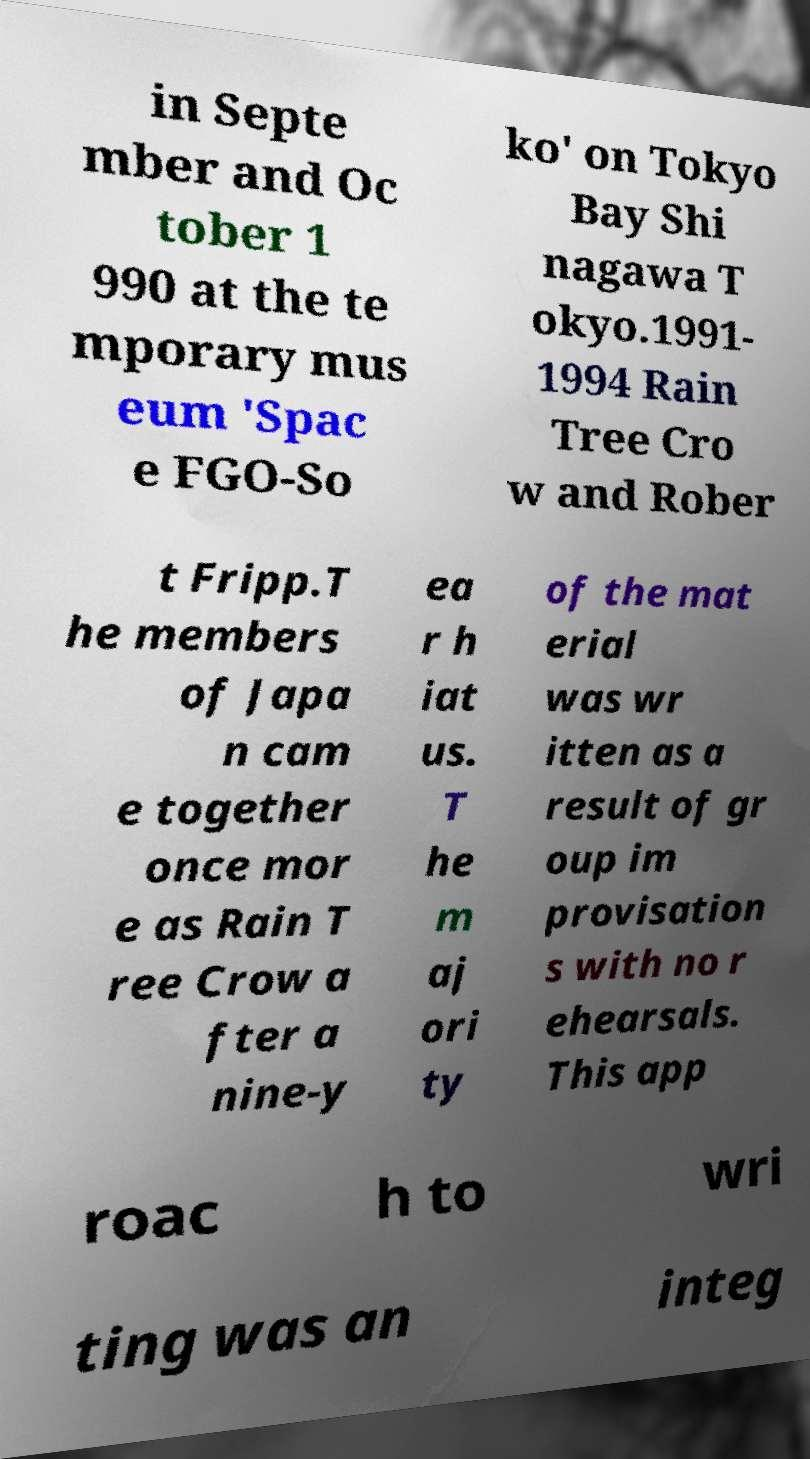What messages or text are displayed in this image? I need them in a readable, typed format. in Septe mber and Oc tober 1 990 at the te mporary mus eum 'Spac e FGO-So ko' on Tokyo Bay Shi nagawa T okyo.1991- 1994 Rain Tree Cro w and Rober t Fripp.T he members of Japa n cam e together once mor e as Rain T ree Crow a fter a nine-y ea r h iat us. T he m aj ori ty of the mat erial was wr itten as a result of gr oup im provisation s with no r ehearsals. This app roac h to wri ting was an integ 